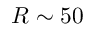<formula> <loc_0><loc_0><loc_500><loc_500>R \sim 5 0</formula> 